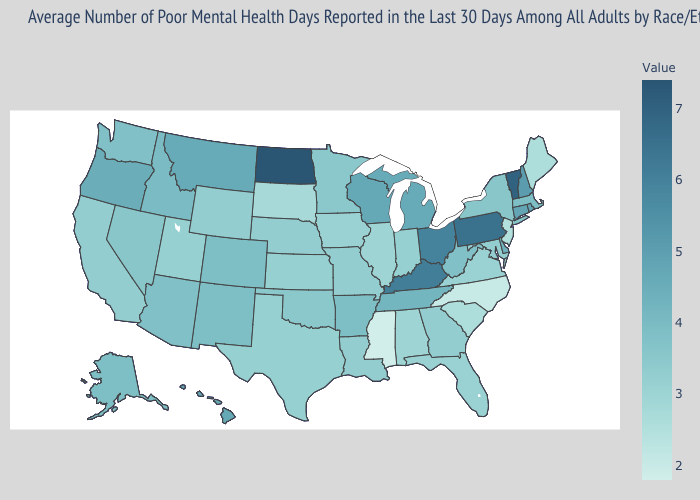Does North Dakota have the highest value in the USA?
Give a very brief answer. Yes. Which states hav the highest value in the Northeast?
Concise answer only. Vermont. Is the legend a continuous bar?
Answer briefly. Yes. Which states have the highest value in the USA?
Concise answer only. North Dakota. 